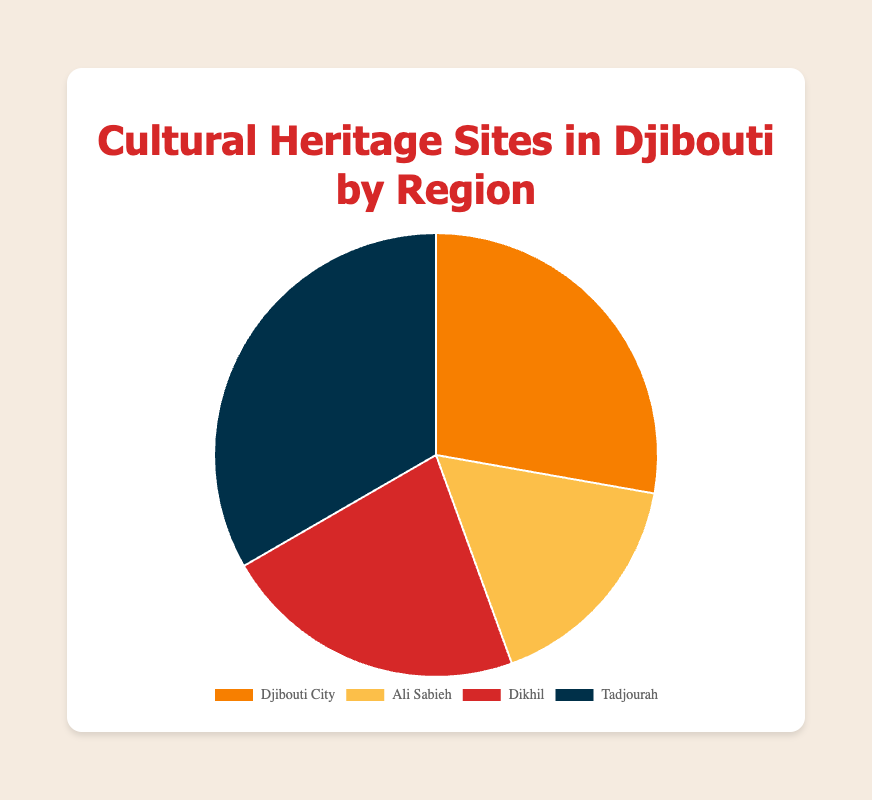What proportion of cultural heritage sites are in Tadjourah? Add the number of heritage sites in all regions: 5 (Djibouti City) + 3 (Ali Sabieh) + 4 (Dikhil) + 6 (Tadjourah) = 18. Tadjourah has 6 sites. Proportion = 6/18 = 1/3
Answer: 1/3 Which region has the highest number of cultural heritage sites? Look at the pie chart to identify which section is the largest. Tadjourah has the most sites with 6.
Answer: Tadjourah Which region has twice as many cultural heritage sites as Ali Sabieh? Ali Sabieh has 3 sites. The region with twice as many would have 6 sites. Tadjourah has 6 sites.
Answer: Tadjourah How many more cultural heritage sites does Djibouti City have compared to Ali Sabieh? Djibouti City has 5 sites; Ali Sabieh has 3 sites. Difference = 5 - 3 = 2
Answer: 2 What is the average number of cultural heritage sites per region? Add the number of sites in all regions: 5 + 3 + 4 + 6 = 18. Divide by the number of regions: 18 / 4 = 4.5
Answer: 4.5 Which region has the smallest number of cultural heritage sites? Look at the pie chart to identify which section is the smallest. Ali Sabieh has the fewest with 3 sites.
Answer: Ali Sabieh What is the ratio of cultural heritage sites between Dikhil and Djibouti City? Dikhil has 4 sites, and Djibouti City has 5 sites. Ratio = 4/5
Answer: 4/5 If 3 more sites were added to Djibouti City, what would its new proportion of the total heritage sites be? Djibouti City would have 5 + 3 = 8 sites. Total sites would be 18 + 3 = 21. Proportion = 8/21.
Answer: 8/21 How many sites would Dikhil need to match Tadjourah's number of sites? Tadjourah has 6 sites, Dikhil has 4. Dikhil needs 6 - 4 = 2 more sites.
Answer: 2 What color represents Ali Sabieh in the pie chart? Visually identify the color assigned to Ali Sabieh. It is light yellow.
Answer: Light yellow 